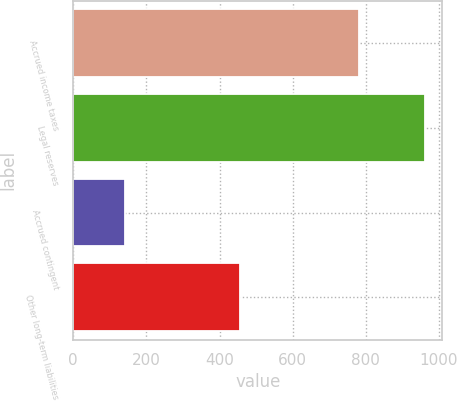Convert chart to OTSL. <chart><loc_0><loc_0><loc_500><loc_500><bar_chart><fcel>Accrued income taxes<fcel>Legal reserves<fcel>Accrued contingent<fcel>Other long-term liabilities<nl><fcel>781<fcel>961<fcel>141<fcel>455<nl></chart> 